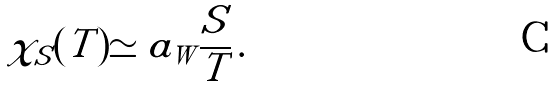<formula> <loc_0><loc_0><loc_500><loc_500>\chi _ { S } ( T ) \simeq a _ { W } \frac { S } { T } \, .</formula> 